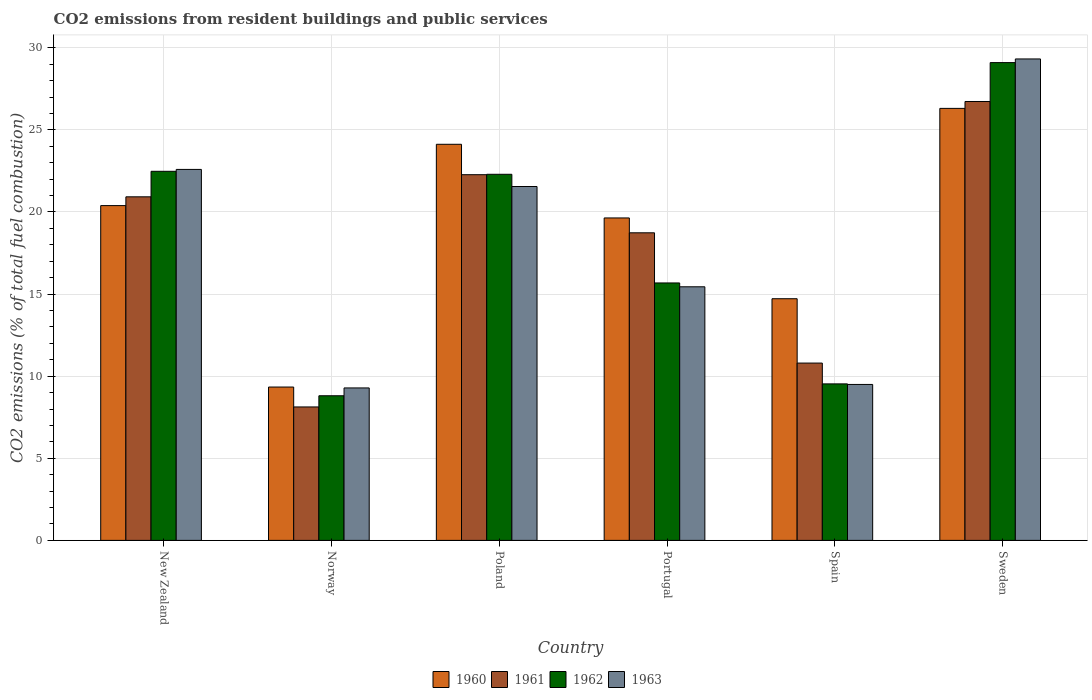How many groups of bars are there?
Provide a short and direct response. 6. Are the number of bars per tick equal to the number of legend labels?
Keep it short and to the point. Yes. What is the label of the 6th group of bars from the left?
Give a very brief answer. Sweden. In how many cases, is the number of bars for a given country not equal to the number of legend labels?
Your response must be concise. 0. What is the total CO2 emitted in 1960 in Norway?
Your response must be concise. 9.34. Across all countries, what is the maximum total CO2 emitted in 1962?
Your answer should be very brief. 29.1. Across all countries, what is the minimum total CO2 emitted in 1961?
Ensure brevity in your answer.  8.13. What is the total total CO2 emitted in 1963 in the graph?
Ensure brevity in your answer.  107.69. What is the difference between the total CO2 emitted in 1961 in Norway and that in Portugal?
Ensure brevity in your answer.  -10.61. What is the difference between the total CO2 emitted in 1960 in Portugal and the total CO2 emitted in 1962 in Sweden?
Give a very brief answer. -9.46. What is the average total CO2 emitted in 1961 per country?
Your response must be concise. 17.93. What is the difference between the total CO2 emitted of/in 1961 and total CO2 emitted of/in 1962 in Portugal?
Offer a very short reply. 3.05. In how many countries, is the total CO2 emitted in 1960 greater than 7?
Offer a very short reply. 6. What is the ratio of the total CO2 emitted in 1961 in New Zealand to that in Poland?
Your answer should be compact. 0.94. What is the difference between the highest and the second highest total CO2 emitted in 1962?
Your answer should be compact. 6.62. What is the difference between the highest and the lowest total CO2 emitted in 1962?
Offer a very short reply. 20.29. Is it the case that in every country, the sum of the total CO2 emitted in 1963 and total CO2 emitted in 1962 is greater than the sum of total CO2 emitted in 1961 and total CO2 emitted in 1960?
Your answer should be compact. No. What does the 3rd bar from the left in Spain represents?
Your response must be concise. 1962. What does the 3rd bar from the right in Sweden represents?
Ensure brevity in your answer.  1961. Is it the case that in every country, the sum of the total CO2 emitted in 1963 and total CO2 emitted in 1961 is greater than the total CO2 emitted in 1960?
Your answer should be compact. Yes. What is the difference between two consecutive major ticks on the Y-axis?
Make the answer very short. 5. Are the values on the major ticks of Y-axis written in scientific E-notation?
Your answer should be very brief. No. Does the graph contain any zero values?
Offer a terse response. No. What is the title of the graph?
Make the answer very short. CO2 emissions from resident buildings and public services. What is the label or title of the X-axis?
Ensure brevity in your answer.  Country. What is the label or title of the Y-axis?
Keep it short and to the point. CO2 emissions (% of total fuel combustion). What is the CO2 emissions (% of total fuel combustion) in 1960 in New Zealand?
Make the answer very short. 20.39. What is the CO2 emissions (% of total fuel combustion) in 1961 in New Zealand?
Offer a very short reply. 20.92. What is the CO2 emissions (% of total fuel combustion) of 1962 in New Zealand?
Ensure brevity in your answer.  22.48. What is the CO2 emissions (% of total fuel combustion) of 1963 in New Zealand?
Offer a very short reply. 22.59. What is the CO2 emissions (% of total fuel combustion) of 1960 in Norway?
Offer a terse response. 9.34. What is the CO2 emissions (% of total fuel combustion) in 1961 in Norway?
Make the answer very short. 8.13. What is the CO2 emissions (% of total fuel combustion) of 1962 in Norway?
Your response must be concise. 8.81. What is the CO2 emissions (% of total fuel combustion) of 1963 in Norway?
Offer a terse response. 9.28. What is the CO2 emissions (% of total fuel combustion) of 1960 in Poland?
Keep it short and to the point. 24.12. What is the CO2 emissions (% of total fuel combustion) in 1961 in Poland?
Offer a terse response. 22.27. What is the CO2 emissions (% of total fuel combustion) of 1962 in Poland?
Provide a succinct answer. 22.3. What is the CO2 emissions (% of total fuel combustion) of 1963 in Poland?
Keep it short and to the point. 21.55. What is the CO2 emissions (% of total fuel combustion) in 1960 in Portugal?
Provide a succinct answer. 19.64. What is the CO2 emissions (% of total fuel combustion) in 1961 in Portugal?
Keep it short and to the point. 18.73. What is the CO2 emissions (% of total fuel combustion) of 1962 in Portugal?
Make the answer very short. 15.68. What is the CO2 emissions (% of total fuel combustion) of 1963 in Portugal?
Provide a short and direct response. 15.44. What is the CO2 emissions (% of total fuel combustion) in 1960 in Spain?
Provide a succinct answer. 14.72. What is the CO2 emissions (% of total fuel combustion) of 1961 in Spain?
Your answer should be very brief. 10.8. What is the CO2 emissions (% of total fuel combustion) of 1962 in Spain?
Your answer should be compact. 9.53. What is the CO2 emissions (% of total fuel combustion) of 1963 in Spain?
Your answer should be compact. 9.5. What is the CO2 emissions (% of total fuel combustion) in 1960 in Sweden?
Your answer should be very brief. 26.31. What is the CO2 emissions (% of total fuel combustion) of 1961 in Sweden?
Ensure brevity in your answer.  26.73. What is the CO2 emissions (% of total fuel combustion) in 1962 in Sweden?
Ensure brevity in your answer.  29.1. What is the CO2 emissions (% of total fuel combustion) in 1963 in Sweden?
Give a very brief answer. 29.32. Across all countries, what is the maximum CO2 emissions (% of total fuel combustion) of 1960?
Offer a terse response. 26.31. Across all countries, what is the maximum CO2 emissions (% of total fuel combustion) in 1961?
Make the answer very short. 26.73. Across all countries, what is the maximum CO2 emissions (% of total fuel combustion) in 1962?
Give a very brief answer. 29.1. Across all countries, what is the maximum CO2 emissions (% of total fuel combustion) of 1963?
Make the answer very short. 29.32. Across all countries, what is the minimum CO2 emissions (% of total fuel combustion) of 1960?
Your response must be concise. 9.34. Across all countries, what is the minimum CO2 emissions (% of total fuel combustion) in 1961?
Provide a short and direct response. 8.13. Across all countries, what is the minimum CO2 emissions (% of total fuel combustion) of 1962?
Provide a succinct answer. 8.81. Across all countries, what is the minimum CO2 emissions (% of total fuel combustion) of 1963?
Keep it short and to the point. 9.28. What is the total CO2 emissions (% of total fuel combustion) of 1960 in the graph?
Keep it short and to the point. 114.51. What is the total CO2 emissions (% of total fuel combustion) in 1961 in the graph?
Ensure brevity in your answer.  107.58. What is the total CO2 emissions (% of total fuel combustion) in 1962 in the graph?
Keep it short and to the point. 107.89. What is the total CO2 emissions (% of total fuel combustion) in 1963 in the graph?
Provide a short and direct response. 107.69. What is the difference between the CO2 emissions (% of total fuel combustion) in 1960 in New Zealand and that in Norway?
Your answer should be very brief. 11.05. What is the difference between the CO2 emissions (% of total fuel combustion) of 1961 in New Zealand and that in Norway?
Keep it short and to the point. 12.8. What is the difference between the CO2 emissions (% of total fuel combustion) in 1962 in New Zealand and that in Norway?
Ensure brevity in your answer.  13.67. What is the difference between the CO2 emissions (% of total fuel combustion) of 1963 in New Zealand and that in Norway?
Offer a very short reply. 13.31. What is the difference between the CO2 emissions (% of total fuel combustion) of 1960 in New Zealand and that in Poland?
Make the answer very short. -3.73. What is the difference between the CO2 emissions (% of total fuel combustion) of 1961 in New Zealand and that in Poland?
Offer a very short reply. -1.35. What is the difference between the CO2 emissions (% of total fuel combustion) in 1962 in New Zealand and that in Poland?
Offer a terse response. 0.18. What is the difference between the CO2 emissions (% of total fuel combustion) in 1963 in New Zealand and that in Poland?
Your response must be concise. 1.04. What is the difference between the CO2 emissions (% of total fuel combustion) of 1960 in New Zealand and that in Portugal?
Make the answer very short. 0.75. What is the difference between the CO2 emissions (% of total fuel combustion) in 1961 in New Zealand and that in Portugal?
Keep it short and to the point. 2.19. What is the difference between the CO2 emissions (% of total fuel combustion) in 1962 in New Zealand and that in Portugal?
Ensure brevity in your answer.  6.8. What is the difference between the CO2 emissions (% of total fuel combustion) in 1963 in New Zealand and that in Portugal?
Your response must be concise. 7.15. What is the difference between the CO2 emissions (% of total fuel combustion) of 1960 in New Zealand and that in Spain?
Provide a succinct answer. 5.67. What is the difference between the CO2 emissions (% of total fuel combustion) in 1961 in New Zealand and that in Spain?
Ensure brevity in your answer.  10.13. What is the difference between the CO2 emissions (% of total fuel combustion) of 1962 in New Zealand and that in Spain?
Provide a succinct answer. 12.95. What is the difference between the CO2 emissions (% of total fuel combustion) in 1963 in New Zealand and that in Spain?
Give a very brief answer. 13.1. What is the difference between the CO2 emissions (% of total fuel combustion) of 1960 in New Zealand and that in Sweden?
Give a very brief answer. -5.92. What is the difference between the CO2 emissions (% of total fuel combustion) in 1961 in New Zealand and that in Sweden?
Ensure brevity in your answer.  -5.81. What is the difference between the CO2 emissions (% of total fuel combustion) of 1962 in New Zealand and that in Sweden?
Provide a short and direct response. -6.62. What is the difference between the CO2 emissions (% of total fuel combustion) of 1963 in New Zealand and that in Sweden?
Provide a short and direct response. -6.73. What is the difference between the CO2 emissions (% of total fuel combustion) in 1960 in Norway and that in Poland?
Your answer should be very brief. -14.78. What is the difference between the CO2 emissions (% of total fuel combustion) of 1961 in Norway and that in Poland?
Keep it short and to the point. -14.14. What is the difference between the CO2 emissions (% of total fuel combustion) of 1962 in Norway and that in Poland?
Your response must be concise. -13.49. What is the difference between the CO2 emissions (% of total fuel combustion) of 1963 in Norway and that in Poland?
Provide a succinct answer. -12.27. What is the difference between the CO2 emissions (% of total fuel combustion) of 1960 in Norway and that in Portugal?
Make the answer very short. -10.3. What is the difference between the CO2 emissions (% of total fuel combustion) in 1961 in Norway and that in Portugal?
Provide a short and direct response. -10.61. What is the difference between the CO2 emissions (% of total fuel combustion) of 1962 in Norway and that in Portugal?
Ensure brevity in your answer.  -6.87. What is the difference between the CO2 emissions (% of total fuel combustion) in 1963 in Norway and that in Portugal?
Your answer should be very brief. -6.16. What is the difference between the CO2 emissions (% of total fuel combustion) of 1960 in Norway and that in Spain?
Your response must be concise. -5.38. What is the difference between the CO2 emissions (% of total fuel combustion) of 1961 in Norway and that in Spain?
Make the answer very short. -2.67. What is the difference between the CO2 emissions (% of total fuel combustion) of 1962 in Norway and that in Spain?
Provide a succinct answer. -0.72. What is the difference between the CO2 emissions (% of total fuel combustion) in 1963 in Norway and that in Spain?
Keep it short and to the point. -0.21. What is the difference between the CO2 emissions (% of total fuel combustion) of 1960 in Norway and that in Sweden?
Offer a terse response. -16.97. What is the difference between the CO2 emissions (% of total fuel combustion) of 1961 in Norway and that in Sweden?
Keep it short and to the point. -18.6. What is the difference between the CO2 emissions (% of total fuel combustion) in 1962 in Norway and that in Sweden?
Provide a succinct answer. -20.29. What is the difference between the CO2 emissions (% of total fuel combustion) of 1963 in Norway and that in Sweden?
Provide a short and direct response. -20.04. What is the difference between the CO2 emissions (% of total fuel combustion) of 1960 in Poland and that in Portugal?
Ensure brevity in your answer.  4.49. What is the difference between the CO2 emissions (% of total fuel combustion) of 1961 in Poland and that in Portugal?
Offer a very short reply. 3.54. What is the difference between the CO2 emissions (% of total fuel combustion) of 1962 in Poland and that in Portugal?
Provide a short and direct response. 6.62. What is the difference between the CO2 emissions (% of total fuel combustion) of 1963 in Poland and that in Portugal?
Your answer should be compact. 6.11. What is the difference between the CO2 emissions (% of total fuel combustion) in 1960 in Poland and that in Spain?
Ensure brevity in your answer.  9.41. What is the difference between the CO2 emissions (% of total fuel combustion) of 1961 in Poland and that in Spain?
Ensure brevity in your answer.  11.47. What is the difference between the CO2 emissions (% of total fuel combustion) in 1962 in Poland and that in Spain?
Offer a terse response. 12.76. What is the difference between the CO2 emissions (% of total fuel combustion) in 1963 in Poland and that in Spain?
Ensure brevity in your answer.  12.05. What is the difference between the CO2 emissions (% of total fuel combustion) in 1960 in Poland and that in Sweden?
Provide a succinct answer. -2.19. What is the difference between the CO2 emissions (% of total fuel combustion) of 1961 in Poland and that in Sweden?
Ensure brevity in your answer.  -4.46. What is the difference between the CO2 emissions (% of total fuel combustion) in 1962 in Poland and that in Sweden?
Make the answer very short. -6.8. What is the difference between the CO2 emissions (% of total fuel combustion) in 1963 in Poland and that in Sweden?
Offer a very short reply. -7.77. What is the difference between the CO2 emissions (% of total fuel combustion) of 1960 in Portugal and that in Spain?
Offer a very short reply. 4.92. What is the difference between the CO2 emissions (% of total fuel combustion) of 1961 in Portugal and that in Spain?
Keep it short and to the point. 7.93. What is the difference between the CO2 emissions (% of total fuel combustion) of 1962 in Portugal and that in Spain?
Your response must be concise. 6.15. What is the difference between the CO2 emissions (% of total fuel combustion) in 1963 in Portugal and that in Spain?
Ensure brevity in your answer.  5.95. What is the difference between the CO2 emissions (% of total fuel combustion) of 1960 in Portugal and that in Sweden?
Your response must be concise. -6.67. What is the difference between the CO2 emissions (% of total fuel combustion) in 1961 in Portugal and that in Sweden?
Make the answer very short. -8. What is the difference between the CO2 emissions (% of total fuel combustion) of 1962 in Portugal and that in Sweden?
Offer a very short reply. -13.42. What is the difference between the CO2 emissions (% of total fuel combustion) of 1963 in Portugal and that in Sweden?
Keep it short and to the point. -13.88. What is the difference between the CO2 emissions (% of total fuel combustion) of 1960 in Spain and that in Sweden?
Your answer should be compact. -11.59. What is the difference between the CO2 emissions (% of total fuel combustion) of 1961 in Spain and that in Sweden?
Make the answer very short. -15.93. What is the difference between the CO2 emissions (% of total fuel combustion) in 1962 in Spain and that in Sweden?
Provide a short and direct response. -19.57. What is the difference between the CO2 emissions (% of total fuel combustion) in 1963 in Spain and that in Sweden?
Keep it short and to the point. -19.82. What is the difference between the CO2 emissions (% of total fuel combustion) of 1960 in New Zealand and the CO2 emissions (% of total fuel combustion) of 1961 in Norway?
Offer a very short reply. 12.26. What is the difference between the CO2 emissions (% of total fuel combustion) in 1960 in New Zealand and the CO2 emissions (% of total fuel combustion) in 1962 in Norway?
Your answer should be compact. 11.58. What is the difference between the CO2 emissions (% of total fuel combustion) in 1960 in New Zealand and the CO2 emissions (% of total fuel combustion) in 1963 in Norway?
Provide a short and direct response. 11.1. What is the difference between the CO2 emissions (% of total fuel combustion) of 1961 in New Zealand and the CO2 emissions (% of total fuel combustion) of 1962 in Norway?
Your answer should be compact. 12.12. What is the difference between the CO2 emissions (% of total fuel combustion) of 1961 in New Zealand and the CO2 emissions (% of total fuel combustion) of 1963 in Norway?
Give a very brief answer. 11.64. What is the difference between the CO2 emissions (% of total fuel combustion) in 1962 in New Zealand and the CO2 emissions (% of total fuel combustion) in 1963 in Norway?
Make the answer very short. 13.19. What is the difference between the CO2 emissions (% of total fuel combustion) in 1960 in New Zealand and the CO2 emissions (% of total fuel combustion) in 1961 in Poland?
Offer a very short reply. -1.88. What is the difference between the CO2 emissions (% of total fuel combustion) of 1960 in New Zealand and the CO2 emissions (% of total fuel combustion) of 1962 in Poland?
Offer a very short reply. -1.91. What is the difference between the CO2 emissions (% of total fuel combustion) in 1960 in New Zealand and the CO2 emissions (% of total fuel combustion) in 1963 in Poland?
Offer a very short reply. -1.16. What is the difference between the CO2 emissions (% of total fuel combustion) in 1961 in New Zealand and the CO2 emissions (% of total fuel combustion) in 1962 in Poland?
Keep it short and to the point. -1.37. What is the difference between the CO2 emissions (% of total fuel combustion) of 1961 in New Zealand and the CO2 emissions (% of total fuel combustion) of 1963 in Poland?
Your response must be concise. -0.63. What is the difference between the CO2 emissions (% of total fuel combustion) in 1962 in New Zealand and the CO2 emissions (% of total fuel combustion) in 1963 in Poland?
Your answer should be very brief. 0.93. What is the difference between the CO2 emissions (% of total fuel combustion) in 1960 in New Zealand and the CO2 emissions (% of total fuel combustion) in 1961 in Portugal?
Your answer should be very brief. 1.66. What is the difference between the CO2 emissions (% of total fuel combustion) in 1960 in New Zealand and the CO2 emissions (% of total fuel combustion) in 1962 in Portugal?
Provide a succinct answer. 4.71. What is the difference between the CO2 emissions (% of total fuel combustion) in 1960 in New Zealand and the CO2 emissions (% of total fuel combustion) in 1963 in Portugal?
Make the answer very short. 4.94. What is the difference between the CO2 emissions (% of total fuel combustion) in 1961 in New Zealand and the CO2 emissions (% of total fuel combustion) in 1962 in Portugal?
Your answer should be compact. 5.25. What is the difference between the CO2 emissions (% of total fuel combustion) of 1961 in New Zealand and the CO2 emissions (% of total fuel combustion) of 1963 in Portugal?
Ensure brevity in your answer.  5.48. What is the difference between the CO2 emissions (% of total fuel combustion) of 1962 in New Zealand and the CO2 emissions (% of total fuel combustion) of 1963 in Portugal?
Offer a very short reply. 7.03. What is the difference between the CO2 emissions (% of total fuel combustion) of 1960 in New Zealand and the CO2 emissions (% of total fuel combustion) of 1961 in Spain?
Provide a succinct answer. 9.59. What is the difference between the CO2 emissions (% of total fuel combustion) of 1960 in New Zealand and the CO2 emissions (% of total fuel combustion) of 1962 in Spain?
Give a very brief answer. 10.86. What is the difference between the CO2 emissions (% of total fuel combustion) in 1960 in New Zealand and the CO2 emissions (% of total fuel combustion) in 1963 in Spain?
Make the answer very short. 10.89. What is the difference between the CO2 emissions (% of total fuel combustion) of 1961 in New Zealand and the CO2 emissions (% of total fuel combustion) of 1962 in Spain?
Offer a terse response. 11.39. What is the difference between the CO2 emissions (% of total fuel combustion) of 1961 in New Zealand and the CO2 emissions (% of total fuel combustion) of 1963 in Spain?
Your answer should be compact. 11.43. What is the difference between the CO2 emissions (% of total fuel combustion) of 1962 in New Zealand and the CO2 emissions (% of total fuel combustion) of 1963 in Spain?
Offer a very short reply. 12.98. What is the difference between the CO2 emissions (% of total fuel combustion) of 1960 in New Zealand and the CO2 emissions (% of total fuel combustion) of 1961 in Sweden?
Ensure brevity in your answer.  -6.34. What is the difference between the CO2 emissions (% of total fuel combustion) of 1960 in New Zealand and the CO2 emissions (% of total fuel combustion) of 1962 in Sweden?
Ensure brevity in your answer.  -8.71. What is the difference between the CO2 emissions (% of total fuel combustion) of 1960 in New Zealand and the CO2 emissions (% of total fuel combustion) of 1963 in Sweden?
Your answer should be very brief. -8.93. What is the difference between the CO2 emissions (% of total fuel combustion) of 1961 in New Zealand and the CO2 emissions (% of total fuel combustion) of 1962 in Sweden?
Provide a short and direct response. -8.17. What is the difference between the CO2 emissions (% of total fuel combustion) in 1961 in New Zealand and the CO2 emissions (% of total fuel combustion) in 1963 in Sweden?
Ensure brevity in your answer.  -8.4. What is the difference between the CO2 emissions (% of total fuel combustion) of 1962 in New Zealand and the CO2 emissions (% of total fuel combustion) of 1963 in Sweden?
Ensure brevity in your answer.  -6.84. What is the difference between the CO2 emissions (% of total fuel combustion) in 1960 in Norway and the CO2 emissions (% of total fuel combustion) in 1961 in Poland?
Provide a succinct answer. -12.93. What is the difference between the CO2 emissions (% of total fuel combustion) in 1960 in Norway and the CO2 emissions (% of total fuel combustion) in 1962 in Poland?
Keep it short and to the point. -12.96. What is the difference between the CO2 emissions (% of total fuel combustion) in 1960 in Norway and the CO2 emissions (% of total fuel combustion) in 1963 in Poland?
Make the answer very short. -12.21. What is the difference between the CO2 emissions (% of total fuel combustion) of 1961 in Norway and the CO2 emissions (% of total fuel combustion) of 1962 in Poland?
Provide a succinct answer. -14.17. What is the difference between the CO2 emissions (% of total fuel combustion) in 1961 in Norway and the CO2 emissions (% of total fuel combustion) in 1963 in Poland?
Keep it short and to the point. -13.42. What is the difference between the CO2 emissions (% of total fuel combustion) in 1962 in Norway and the CO2 emissions (% of total fuel combustion) in 1963 in Poland?
Ensure brevity in your answer.  -12.74. What is the difference between the CO2 emissions (% of total fuel combustion) of 1960 in Norway and the CO2 emissions (% of total fuel combustion) of 1961 in Portugal?
Keep it short and to the point. -9.39. What is the difference between the CO2 emissions (% of total fuel combustion) in 1960 in Norway and the CO2 emissions (% of total fuel combustion) in 1962 in Portugal?
Your answer should be compact. -6.34. What is the difference between the CO2 emissions (% of total fuel combustion) in 1960 in Norway and the CO2 emissions (% of total fuel combustion) in 1963 in Portugal?
Your answer should be very brief. -6.1. What is the difference between the CO2 emissions (% of total fuel combustion) in 1961 in Norway and the CO2 emissions (% of total fuel combustion) in 1962 in Portugal?
Provide a succinct answer. -7.55. What is the difference between the CO2 emissions (% of total fuel combustion) in 1961 in Norway and the CO2 emissions (% of total fuel combustion) in 1963 in Portugal?
Make the answer very short. -7.32. What is the difference between the CO2 emissions (% of total fuel combustion) of 1962 in Norway and the CO2 emissions (% of total fuel combustion) of 1963 in Portugal?
Provide a short and direct response. -6.64. What is the difference between the CO2 emissions (% of total fuel combustion) of 1960 in Norway and the CO2 emissions (% of total fuel combustion) of 1961 in Spain?
Make the answer very short. -1.46. What is the difference between the CO2 emissions (% of total fuel combustion) of 1960 in Norway and the CO2 emissions (% of total fuel combustion) of 1962 in Spain?
Provide a succinct answer. -0.19. What is the difference between the CO2 emissions (% of total fuel combustion) in 1960 in Norway and the CO2 emissions (% of total fuel combustion) in 1963 in Spain?
Give a very brief answer. -0.16. What is the difference between the CO2 emissions (% of total fuel combustion) of 1961 in Norway and the CO2 emissions (% of total fuel combustion) of 1962 in Spain?
Give a very brief answer. -1.4. What is the difference between the CO2 emissions (% of total fuel combustion) in 1961 in Norway and the CO2 emissions (% of total fuel combustion) in 1963 in Spain?
Offer a terse response. -1.37. What is the difference between the CO2 emissions (% of total fuel combustion) of 1962 in Norway and the CO2 emissions (% of total fuel combustion) of 1963 in Spain?
Keep it short and to the point. -0.69. What is the difference between the CO2 emissions (% of total fuel combustion) in 1960 in Norway and the CO2 emissions (% of total fuel combustion) in 1961 in Sweden?
Provide a succinct answer. -17.39. What is the difference between the CO2 emissions (% of total fuel combustion) of 1960 in Norway and the CO2 emissions (% of total fuel combustion) of 1962 in Sweden?
Keep it short and to the point. -19.76. What is the difference between the CO2 emissions (% of total fuel combustion) of 1960 in Norway and the CO2 emissions (% of total fuel combustion) of 1963 in Sweden?
Your response must be concise. -19.98. What is the difference between the CO2 emissions (% of total fuel combustion) in 1961 in Norway and the CO2 emissions (% of total fuel combustion) in 1962 in Sweden?
Offer a very short reply. -20.97. What is the difference between the CO2 emissions (% of total fuel combustion) in 1961 in Norway and the CO2 emissions (% of total fuel combustion) in 1963 in Sweden?
Your answer should be very brief. -21.19. What is the difference between the CO2 emissions (% of total fuel combustion) of 1962 in Norway and the CO2 emissions (% of total fuel combustion) of 1963 in Sweden?
Provide a short and direct response. -20.51. What is the difference between the CO2 emissions (% of total fuel combustion) of 1960 in Poland and the CO2 emissions (% of total fuel combustion) of 1961 in Portugal?
Your response must be concise. 5.39. What is the difference between the CO2 emissions (% of total fuel combustion) in 1960 in Poland and the CO2 emissions (% of total fuel combustion) in 1962 in Portugal?
Keep it short and to the point. 8.44. What is the difference between the CO2 emissions (% of total fuel combustion) in 1960 in Poland and the CO2 emissions (% of total fuel combustion) in 1963 in Portugal?
Ensure brevity in your answer.  8.68. What is the difference between the CO2 emissions (% of total fuel combustion) in 1961 in Poland and the CO2 emissions (% of total fuel combustion) in 1962 in Portugal?
Provide a succinct answer. 6.59. What is the difference between the CO2 emissions (% of total fuel combustion) in 1961 in Poland and the CO2 emissions (% of total fuel combustion) in 1963 in Portugal?
Offer a very short reply. 6.83. What is the difference between the CO2 emissions (% of total fuel combustion) of 1962 in Poland and the CO2 emissions (% of total fuel combustion) of 1963 in Portugal?
Your answer should be compact. 6.85. What is the difference between the CO2 emissions (% of total fuel combustion) in 1960 in Poland and the CO2 emissions (% of total fuel combustion) in 1961 in Spain?
Provide a short and direct response. 13.32. What is the difference between the CO2 emissions (% of total fuel combustion) in 1960 in Poland and the CO2 emissions (% of total fuel combustion) in 1962 in Spain?
Ensure brevity in your answer.  14.59. What is the difference between the CO2 emissions (% of total fuel combustion) of 1960 in Poland and the CO2 emissions (% of total fuel combustion) of 1963 in Spain?
Your answer should be compact. 14.63. What is the difference between the CO2 emissions (% of total fuel combustion) of 1961 in Poland and the CO2 emissions (% of total fuel combustion) of 1962 in Spain?
Your response must be concise. 12.74. What is the difference between the CO2 emissions (% of total fuel combustion) in 1961 in Poland and the CO2 emissions (% of total fuel combustion) in 1963 in Spain?
Offer a very short reply. 12.77. What is the difference between the CO2 emissions (% of total fuel combustion) in 1962 in Poland and the CO2 emissions (% of total fuel combustion) in 1963 in Spain?
Keep it short and to the point. 12.8. What is the difference between the CO2 emissions (% of total fuel combustion) in 1960 in Poland and the CO2 emissions (% of total fuel combustion) in 1961 in Sweden?
Provide a short and direct response. -2.61. What is the difference between the CO2 emissions (% of total fuel combustion) of 1960 in Poland and the CO2 emissions (% of total fuel combustion) of 1962 in Sweden?
Give a very brief answer. -4.97. What is the difference between the CO2 emissions (% of total fuel combustion) in 1960 in Poland and the CO2 emissions (% of total fuel combustion) in 1963 in Sweden?
Give a very brief answer. -5.2. What is the difference between the CO2 emissions (% of total fuel combustion) in 1961 in Poland and the CO2 emissions (% of total fuel combustion) in 1962 in Sweden?
Offer a terse response. -6.83. What is the difference between the CO2 emissions (% of total fuel combustion) in 1961 in Poland and the CO2 emissions (% of total fuel combustion) in 1963 in Sweden?
Provide a short and direct response. -7.05. What is the difference between the CO2 emissions (% of total fuel combustion) in 1962 in Poland and the CO2 emissions (% of total fuel combustion) in 1963 in Sweden?
Your response must be concise. -7.02. What is the difference between the CO2 emissions (% of total fuel combustion) of 1960 in Portugal and the CO2 emissions (% of total fuel combustion) of 1961 in Spain?
Provide a short and direct response. 8.84. What is the difference between the CO2 emissions (% of total fuel combustion) of 1960 in Portugal and the CO2 emissions (% of total fuel combustion) of 1962 in Spain?
Give a very brief answer. 10.11. What is the difference between the CO2 emissions (% of total fuel combustion) of 1960 in Portugal and the CO2 emissions (% of total fuel combustion) of 1963 in Spain?
Ensure brevity in your answer.  10.14. What is the difference between the CO2 emissions (% of total fuel combustion) in 1961 in Portugal and the CO2 emissions (% of total fuel combustion) in 1962 in Spain?
Give a very brief answer. 9.2. What is the difference between the CO2 emissions (% of total fuel combustion) in 1961 in Portugal and the CO2 emissions (% of total fuel combustion) in 1963 in Spain?
Provide a succinct answer. 9.23. What is the difference between the CO2 emissions (% of total fuel combustion) of 1962 in Portugal and the CO2 emissions (% of total fuel combustion) of 1963 in Spain?
Your response must be concise. 6.18. What is the difference between the CO2 emissions (% of total fuel combustion) of 1960 in Portugal and the CO2 emissions (% of total fuel combustion) of 1961 in Sweden?
Provide a succinct answer. -7.09. What is the difference between the CO2 emissions (% of total fuel combustion) in 1960 in Portugal and the CO2 emissions (% of total fuel combustion) in 1962 in Sweden?
Provide a short and direct response. -9.46. What is the difference between the CO2 emissions (% of total fuel combustion) in 1960 in Portugal and the CO2 emissions (% of total fuel combustion) in 1963 in Sweden?
Your answer should be compact. -9.68. What is the difference between the CO2 emissions (% of total fuel combustion) in 1961 in Portugal and the CO2 emissions (% of total fuel combustion) in 1962 in Sweden?
Offer a very short reply. -10.36. What is the difference between the CO2 emissions (% of total fuel combustion) of 1961 in Portugal and the CO2 emissions (% of total fuel combustion) of 1963 in Sweden?
Your response must be concise. -10.59. What is the difference between the CO2 emissions (% of total fuel combustion) of 1962 in Portugal and the CO2 emissions (% of total fuel combustion) of 1963 in Sweden?
Offer a terse response. -13.64. What is the difference between the CO2 emissions (% of total fuel combustion) in 1960 in Spain and the CO2 emissions (% of total fuel combustion) in 1961 in Sweden?
Ensure brevity in your answer.  -12.01. What is the difference between the CO2 emissions (% of total fuel combustion) of 1960 in Spain and the CO2 emissions (% of total fuel combustion) of 1962 in Sweden?
Make the answer very short. -14.38. What is the difference between the CO2 emissions (% of total fuel combustion) of 1960 in Spain and the CO2 emissions (% of total fuel combustion) of 1963 in Sweden?
Offer a terse response. -14.6. What is the difference between the CO2 emissions (% of total fuel combustion) of 1961 in Spain and the CO2 emissions (% of total fuel combustion) of 1962 in Sweden?
Make the answer very short. -18.3. What is the difference between the CO2 emissions (% of total fuel combustion) in 1961 in Spain and the CO2 emissions (% of total fuel combustion) in 1963 in Sweden?
Offer a terse response. -18.52. What is the difference between the CO2 emissions (% of total fuel combustion) of 1962 in Spain and the CO2 emissions (% of total fuel combustion) of 1963 in Sweden?
Your response must be concise. -19.79. What is the average CO2 emissions (% of total fuel combustion) in 1960 per country?
Your answer should be very brief. 19.09. What is the average CO2 emissions (% of total fuel combustion) in 1961 per country?
Offer a terse response. 17.93. What is the average CO2 emissions (% of total fuel combustion) in 1962 per country?
Offer a very short reply. 17.98. What is the average CO2 emissions (% of total fuel combustion) in 1963 per country?
Make the answer very short. 17.95. What is the difference between the CO2 emissions (% of total fuel combustion) in 1960 and CO2 emissions (% of total fuel combustion) in 1961 in New Zealand?
Ensure brevity in your answer.  -0.54. What is the difference between the CO2 emissions (% of total fuel combustion) of 1960 and CO2 emissions (% of total fuel combustion) of 1962 in New Zealand?
Keep it short and to the point. -2.09. What is the difference between the CO2 emissions (% of total fuel combustion) in 1960 and CO2 emissions (% of total fuel combustion) in 1963 in New Zealand?
Offer a very short reply. -2.2. What is the difference between the CO2 emissions (% of total fuel combustion) of 1961 and CO2 emissions (% of total fuel combustion) of 1962 in New Zealand?
Ensure brevity in your answer.  -1.55. What is the difference between the CO2 emissions (% of total fuel combustion) in 1961 and CO2 emissions (% of total fuel combustion) in 1963 in New Zealand?
Make the answer very short. -1.67. What is the difference between the CO2 emissions (% of total fuel combustion) of 1962 and CO2 emissions (% of total fuel combustion) of 1963 in New Zealand?
Your answer should be compact. -0.12. What is the difference between the CO2 emissions (% of total fuel combustion) in 1960 and CO2 emissions (% of total fuel combustion) in 1961 in Norway?
Ensure brevity in your answer.  1.21. What is the difference between the CO2 emissions (% of total fuel combustion) in 1960 and CO2 emissions (% of total fuel combustion) in 1962 in Norway?
Your response must be concise. 0.53. What is the difference between the CO2 emissions (% of total fuel combustion) of 1960 and CO2 emissions (% of total fuel combustion) of 1963 in Norway?
Keep it short and to the point. 0.05. What is the difference between the CO2 emissions (% of total fuel combustion) of 1961 and CO2 emissions (% of total fuel combustion) of 1962 in Norway?
Keep it short and to the point. -0.68. What is the difference between the CO2 emissions (% of total fuel combustion) in 1961 and CO2 emissions (% of total fuel combustion) in 1963 in Norway?
Your answer should be very brief. -1.16. What is the difference between the CO2 emissions (% of total fuel combustion) in 1962 and CO2 emissions (% of total fuel combustion) in 1963 in Norway?
Make the answer very short. -0.48. What is the difference between the CO2 emissions (% of total fuel combustion) in 1960 and CO2 emissions (% of total fuel combustion) in 1961 in Poland?
Ensure brevity in your answer.  1.85. What is the difference between the CO2 emissions (% of total fuel combustion) in 1960 and CO2 emissions (% of total fuel combustion) in 1962 in Poland?
Give a very brief answer. 1.83. What is the difference between the CO2 emissions (% of total fuel combustion) in 1960 and CO2 emissions (% of total fuel combustion) in 1963 in Poland?
Your response must be concise. 2.57. What is the difference between the CO2 emissions (% of total fuel combustion) in 1961 and CO2 emissions (% of total fuel combustion) in 1962 in Poland?
Make the answer very short. -0.02. What is the difference between the CO2 emissions (% of total fuel combustion) of 1961 and CO2 emissions (% of total fuel combustion) of 1963 in Poland?
Your answer should be very brief. 0.72. What is the difference between the CO2 emissions (% of total fuel combustion) of 1962 and CO2 emissions (% of total fuel combustion) of 1963 in Poland?
Offer a very short reply. 0.74. What is the difference between the CO2 emissions (% of total fuel combustion) in 1960 and CO2 emissions (% of total fuel combustion) in 1961 in Portugal?
Provide a succinct answer. 0.91. What is the difference between the CO2 emissions (% of total fuel combustion) of 1960 and CO2 emissions (% of total fuel combustion) of 1962 in Portugal?
Your response must be concise. 3.96. What is the difference between the CO2 emissions (% of total fuel combustion) of 1960 and CO2 emissions (% of total fuel combustion) of 1963 in Portugal?
Provide a short and direct response. 4.19. What is the difference between the CO2 emissions (% of total fuel combustion) of 1961 and CO2 emissions (% of total fuel combustion) of 1962 in Portugal?
Your response must be concise. 3.05. What is the difference between the CO2 emissions (% of total fuel combustion) of 1961 and CO2 emissions (% of total fuel combustion) of 1963 in Portugal?
Provide a succinct answer. 3.29. What is the difference between the CO2 emissions (% of total fuel combustion) of 1962 and CO2 emissions (% of total fuel combustion) of 1963 in Portugal?
Give a very brief answer. 0.23. What is the difference between the CO2 emissions (% of total fuel combustion) in 1960 and CO2 emissions (% of total fuel combustion) in 1961 in Spain?
Offer a very short reply. 3.92. What is the difference between the CO2 emissions (% of total fuel combustion) of 1960 and CO2 emissions (% of total fuel combustion) of 1962 in Spain?
Provide a short and direct response. 5.19. What is the difference between the CO2 emissions (% of total fuel combustion) of 1960 and CO2 emissions (% of total fuel combustion) of 1963 in Spain?
Your response must be concise. 5.22. What is the difference between the CO2 emissions (% of total fuel combustion) of 1961 and CO2 emissions (% of total fuel combustion) of 1962 in Spain?
Ensure brevity in your answer.  1.27. What is the difference between the CO2 emissions (% of total fuel combustion) in 1961 and CO2 emissions (% of total fuel combustion) in 1963 in Spain?
Make the answer very short. 1.3. What is the difference between the CO2 emissions (% of total fuel combustion) of 1962 and CO2 emissions (% of total fuel combustion) of 1963 in Spain?
Make the answer very short. 0.03. What is the difference between the CO2 emissions (% of total fuel combustion) of 1960 and CO2 emissions (% of total fuel combustion) of 1961 in Sweden?
Your answer should be very brief. -0.42. What is the difference between the CO2 emissions (% of total fuel combustion) in 1960 and CO2 emissions (% of total fuel combustion) in 1962 in Sweden?
Offer a very short reply. -2.79. What is the difference between the CO2 emissions (% of total fuel combustion) of 1960 and CO2 emissions (% of total fuel combustion) of 1963 in Sweden?
Your answer should be compact. -3.01. What is the difference between the CO2 emissions (% of total fuel combustion) in 1961 and CO2 emissions (% of total fuel combustion) in 1962 in Sweden?
Your answer should be compact. -2.37. What is the difference between the CO2 emissions (% of total fuel combustion) of 1961 and CO2 emissions (% of total fuel combustion) of 1963 in Sweden?
Your answer should be compact. -2.59. What is the difference between the CO2 emissions (% of total fuel combustion) in 1962 and CO2 emissions (% of total fuel combustion) in 1963 in Sweden?
Your response must be concise. -0.22. What is the ratio of the CO2 emissions (% of total fuel combustion) in 1960 in New Zealand to that in Norway?
Ensure brevity in your answer.  2.18. What is the ratio of the CO2 emissions (% of total fuel combustion) in 1961 in New Zealand to that in Norway?
Give a very brief answer. 2.57. What is the ratio of the CO2 emissions (% of total fuel combustion) of 1962 in New Zealand to that in Norway?
Ensure brevity in your answer.  2.55. What is the ratio of the CO2 emissions (% of total fuel combustion) in 1963 in New Zealand to that in Norway?
Make the answer very short. 2.43. What is the ratio of the CO2 emissions (% of total fuel combustion) of 1960 in New Zealand to that in Poland?
Provide a short and direct response. 0.85. What is the ratio of the CO2 emissions (% of total fuel combustion) of 1961 in New Zealand to that in Poland?
Keep it short and to the point. 0.94. What is the ratio of the CO2 emissions (% of total fuel combustion) of 1962 in New Zealand to that in Poland?
Keep it short and to the point. 1.01. What is the ratio of the CO2 emissions (% of total fuel combustion) in 1963 in New Zealand to that in Poland?
Ensure brevity in your answer.  1.05. What is the ratio of the CO2 emissions (% of total fuel combustion) in 1960 in New Zealand to that in Portugal?
Provide a succinct answer. 1.04. What is the ratio of the CO2 emissions (% of total fuel combustion) of 1961 in New Zealand to that in Portugal?
Offer a very short reply. 1.12. What is the ratio of the CO2 emissions (% of total fuel combustion) of 1962 in New Zealand to that in Portugal?
Make the answer very short. 1.43. What is the ratio of the CO2 emissions (% of total fuel combustion) of 1963 in New Zealand to that in Portugal?
Your response must be concise. 1.46. What is the ratio of the CO2 emissions (% of total fuel combustion) in 1960 in New Zealand to that in Spain?
Your answer should be very brief. 1.39. What is the ratio of the CO2 emissions (% of total fuel combustion) in 1961 in New Zealand to that in Spain?
Offer a terse response. 1.94. What is the ratio of the CO2 emissions (% of total fuel combustion) of 1962 in New Zealand to that in Spain?
Ensure brevity in your answer.  2.36. What is the ratio of the CO2 emissions (% of total fuel combustion) of 1963 in New Zealand to that in Spain?
Provide a succinct answer. 2.38. What is the ratio of the CO2 emissions (% of total fuel combustion) of 1960 in New Zealand to that in Sweden?
Make the answer very short. 0.78. What is the ratio of the CO2 emissions (% of total fuel combustion) of 1961 in New Zealand to that in Sweden?
Ensure brevity in your answer.  0.78. What is the ratio of the CO2 emissions (% of total fuel combustion) of 1962 in New Zealand to that in Sweden?
Keep it short and to the point. 0.77. What is the ratio of the CO2 emissions (% of total fuel combustion) of 1963 in New Zealand to that in Sweden?
Give a very brief answer. 0.77. What is the ratio of the CO2 emissions (% of total fuel combustion) in 1960 in Norway to that in Poland?
Offer a very short reply. 0.39. What is the ratio of the CO2 emissions (% of total fuel combustion) of 1961 in Norway to that in Poland?
Keep it short and to the point. 0.36. What is the ratio of the CO2 emissions (% of total fuel combustion) in 1962 in Norway to that in Poland?
Your answer should be very brief. 0.4. What is the ratio of the CO2 emissions (% of total fuel combustion) of 1963 in Norway to that in Poland?
Your response must be concise. 0.43. What is the ratio of the CO2 emissions (% of total fuel combustion) in 1960 in Norway to that in Portugal?
Ensure brevity in your answer.  0.48. What is the ratio of the CO2 emissions (% of total fuel combustion) in 1961 in Norway to that in Portugal?
Give a very brief answer. 0.43. What is the ratio of the CO2 emissions (% of total fuel combustion) of 1962 in Norway to that in Portugal?
Your response must be concise. 0.56. What is the ratio of the CO2 emissions (% of total fuel combustion) of 1963 in Norway to that in Portugal?
Ensure brevity in your answer.  0.6. What is the ratio of the CO2 emissions (% of total fuel combustion) of 1960 in Norway to that in Spain?
Provide a succinct answer. 0.63. What is the ratio of the CO2 emissions (% of total fuel combustion) of 1961 in Norway to that in Spain?
Keep it short and to the point. 0.75. What is the ratio of the CO2 emissions (% of total fuel combustion) of 1962 in Norway to that in Spain?
Offer a very short reply. 0.92. What is the ratio of the CO2 emissions (% of total fuel combustion) of 1963 in Norway to that in Spain?
Give a very brief answer. 0.98. What is the ratio of the CO2 emissions (% of total fuel combustion) of 1960 in Norway to that in Sweden?
Give a very brief answer. 0.35. What is the ratio of the CO2 emissions (% of total fuel combustion) in 1961 in Norway to that in Sweden?
Offer a terse response. 0.3. What is the ratio of the CO2 emissions (% of total fuel combustion) in 1962 in Norway to that in Sweden?
Offer a very short reply. 0.3. What is the ratio of the CO2 emissions (% of total fuel combustion) in 1963 in Norway to that in Sweden?
Provide a short and direct response. 0.32. What is the ratio of the CO2 emissions (% of total fuel combustion) of 1960 in Poland to that in Portugal?
Ensure brevity in your answer.  1.23. What is the ratio of the CO2 emissions (% of total fuel combustion) in 1961 in Poland to that in Portugal?
Make the answer very short. 1.19. What is the ratio of the CO2 emissions (% of total fuel combustion) of 1962 in Poland to that in Portugal?
Provide a succinct answer. 1.42. What is the ratio of the CO2 emissions (% of total fuel combustion) in 1963 in Poland to that in Portugal?
Make the answer very short. 1.4. What is the ratio of the CO2 emissions (% of total fuel combustion) of 1960 in Poland to that in Spain?
Your response must be concise. 1.64. What is the ratio of the CO2 emissions (% of total fuel combustion) of 1961 in Poland to that in Spain?
Provide a short and direct response. 2.06. What is the ratio of the CO2 emissions (% of total fuel combustion) of 1962 in Poland to that in Spain?
Offer a terse response. 2.34. What is the ratio of the CO2 emissions (% of total fuel combustion) in 1963 in Poland to that in Spain?
Offer a terse response. 2.27. What is the ratio of the CO2 emissions (% of total fuel combustion) of 1960 in Poland to that in Sweden?
Keep it short and to the point. 0.92. What is the ratio of the CO2 emissions (% of total fuel combustion) in 1961 in Poland to that in Sweden?
Offer a very short reply. 0.83. What is the ratio of the CO2 emissions (% of total fuel combustion) of 1962 in Poland to that in Sweden?
Give a very brief answer. 0.77. What is the ratio of the CO2 emissions (% of total fuel combustion) of 1963 in Poland to that in Sweden?
Your response must be concise. 0.73. What is the ratio of the CO2 emissions (% of total fuel combustion) of 1960 in Portugal to that in Spain?
Your answer should be compact. 1.33. What is the ratio of the CO2 emissions (% of total fuel combustion) of 1961 in Portugal to that in Spain?
Keep it short and to the point. 1.73. What is the ratio of the CO2 emissions (% of total fuel combustion) of 1962 in Portugal to that in Spain?
Keep it short and to the point. 1.64. What is the ratio of the CO2 emissions (% of total fuel combustion) in 1963 in Portugal to that in Spain?
Keep it short and to the point. 1.63. What is the ratio of the CO2 emissions (% of total fuel combustion) of 1960 in Portugal to that in Sweden?
Provide a succinct answer. 0.75. What is the ratio of the CO2 emissions (% of total fuel combustion) in 1961 in Portugal to that in Sweden?
Give a very brief answer. 0.7. What is the ratio of the CO2 emissions (% of total fuel combustion) in 1962 in Portugal to that in Sweden?
Your answer should be very brief. 0.54. What is the ratio of the CO2 emissions (% of total fuel combustion) in 1963 in Portugal to that in Sweden?
Give a very brief answer. 0.53. What is the ratio of the CO2 emissions (% of total fuel combustion) of 1960 in Spain to that in Sweden?
Ensure brevity in your answer.  0.56. What is the ratio of the CO2 emissions (% of total fuel combustion) in 1961 in Spain to that in Sweden?
Your answer should be compact. 0.4. What is the ratio of the CO2 emissions (% of total fuel combustion) of 1962 in Spain to that in Sweden?
Offer a terse response. 0.33. What is the ratio of the CO2 emissions (% of total fuel combustion) of 1963 in Spain to that in Sweden?
Ensure brevity in your answer.  0.32. What is the difference between the highest and the second highest CO2 emissions (% of total fuel combustion) in 1960?
Make the answer very short. 2.19. What is the difference between the highest and the second highest CO2 emissions (% of total fuel combustion) of 1961?
Make the answer very short. 4.46. What is the difference between the highest and the second highest CO2 emissions (% of total fuel combustion) of 1962?
Your response must be concise. 6.62. What is the difference between the highest and the second highest CO2 emissions (% of total fuel combustion) in 1963?
Offer a terse response. 6.73. What is the difference between the highest and the lowest CO2 emissions (% of total fuel combustion) in 1960?
Your answer should be very brief. 16.97. What is the difference between the highest and the lowest CO2 emissions (% of total fuel combustion) in 1961?
Your answer should be very brief. 18.6. What is the difference between the highest and the lowest CO2 emissions (% of total fuel combustion) in 1962?
Make the answer very short. 20.29. What is the difference between the highest and the lowest CO2 emissions (% of total fuel combustion) of 1963?
Give a very brief answer. 20.04. 